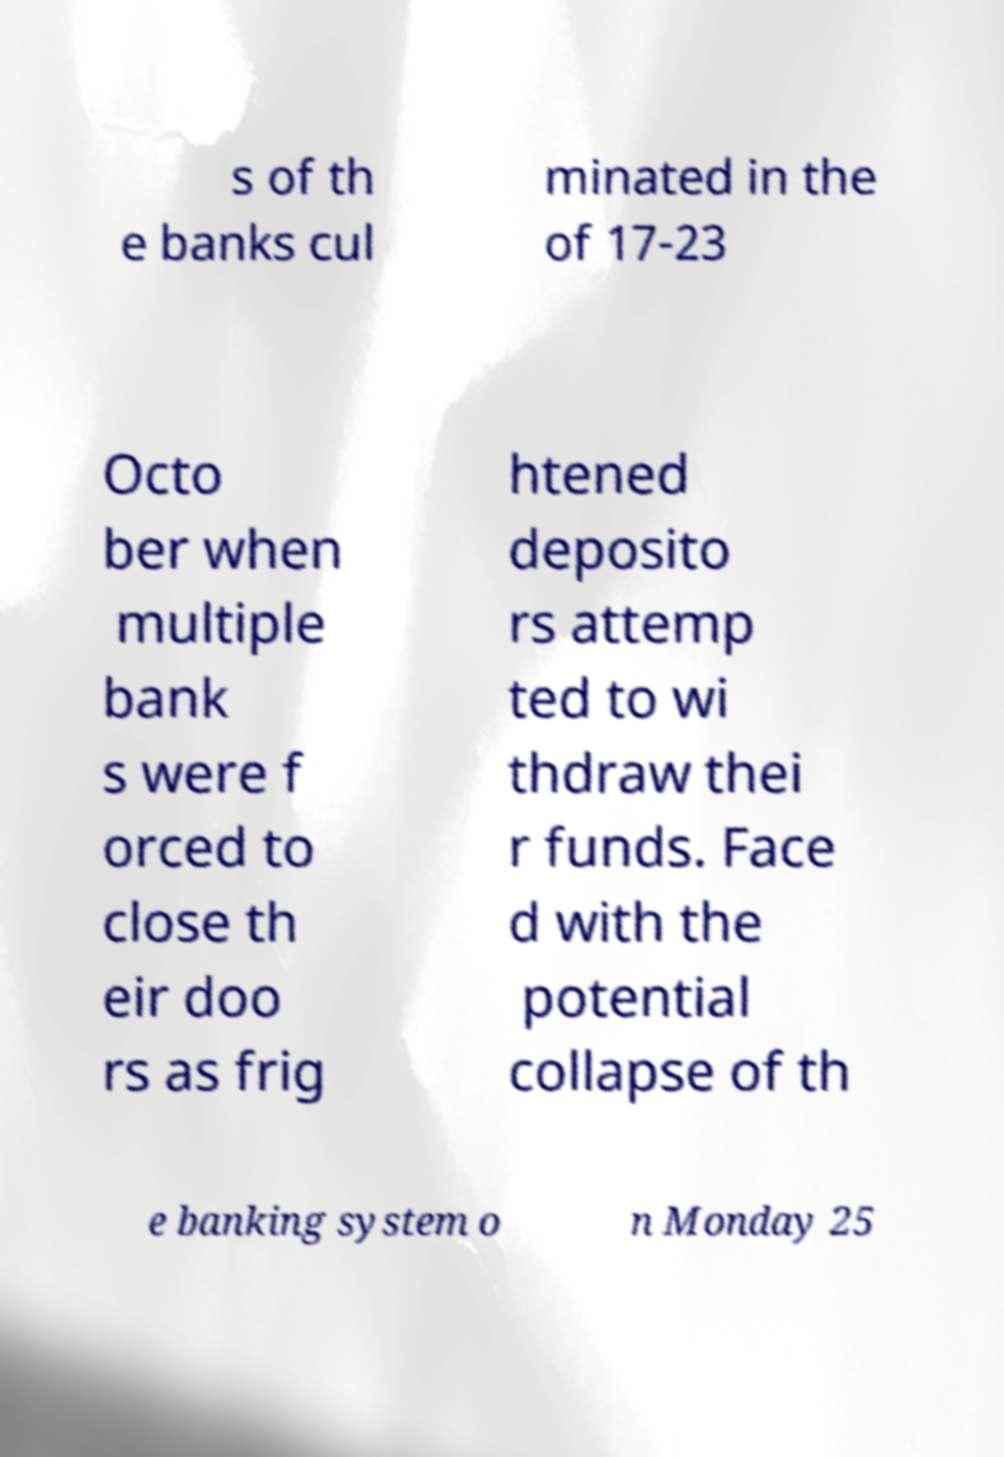What messages or text are displayed in this image? I need them in a readable, typed format. s of th e banks cul minated in the of 17-23 Octo ber when multiple bank s were f orced to close th eir doo rs as frig htened deposito rs attemp ted to wi thdraw thei r funds. Face d with the potential collapse of th e banking system o n Monday 25 